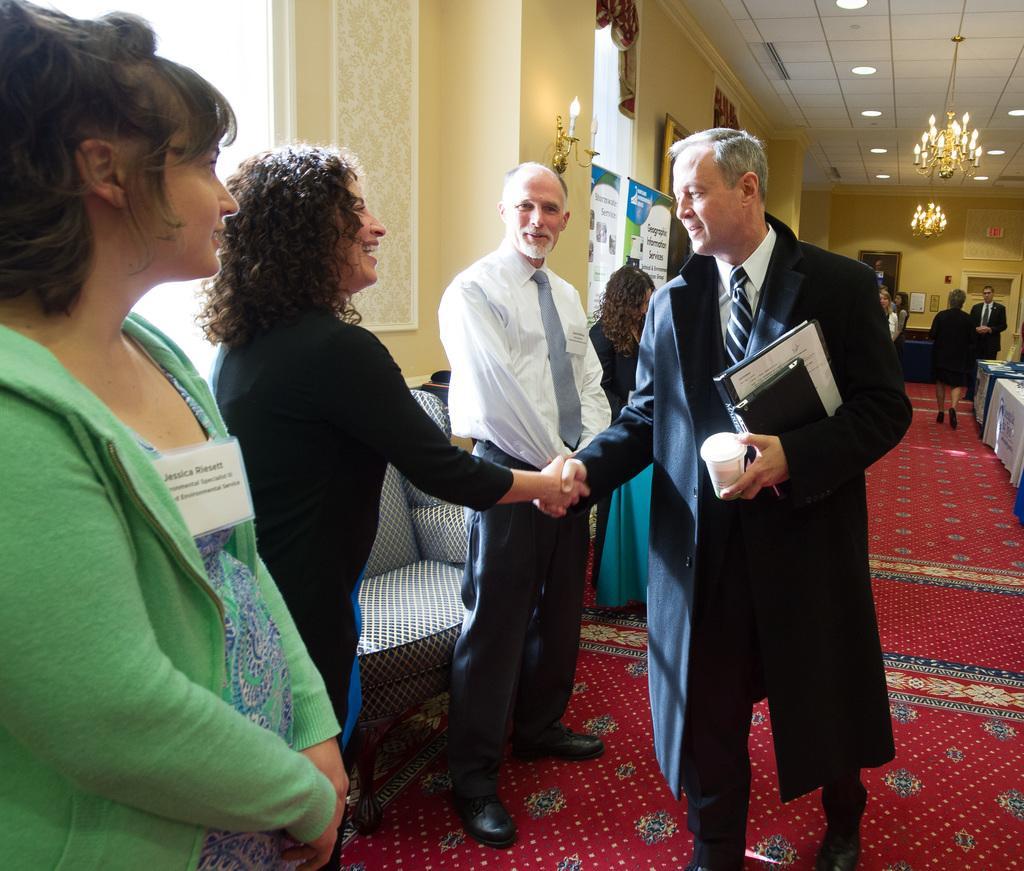Can you describe this image briefly? In this image, we can see people and some are wearing id cards and we can see people shaking hands and one of them is holding some objects. In the background, there are lights, boards and we can see frames on the wall and there are some other people, chairs and there are curtains. At the bottom, there is a carpet. 